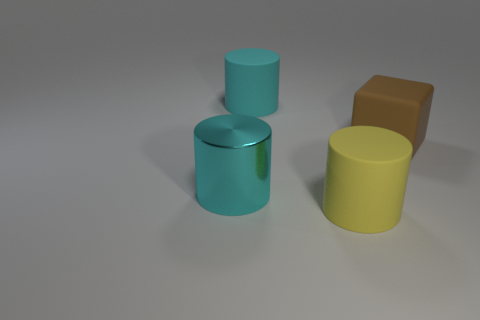Subtract all purple spheres. How many cyan cylinders are left? 2 Add 2 large brown matte things. How many objects exist? 6 Subtract all cubes. How many objects are left? 3 Add 1 gray cylinders. How many gray cylinders exist? 1 Subtract 0 purple cylinders. How many objects are left? 4 Subtract all yellow rubber cylinders. Subtract all rubber blocks. How many objects are left? 2 Add 4 large matte objects. How many large matte objects are left? 7 